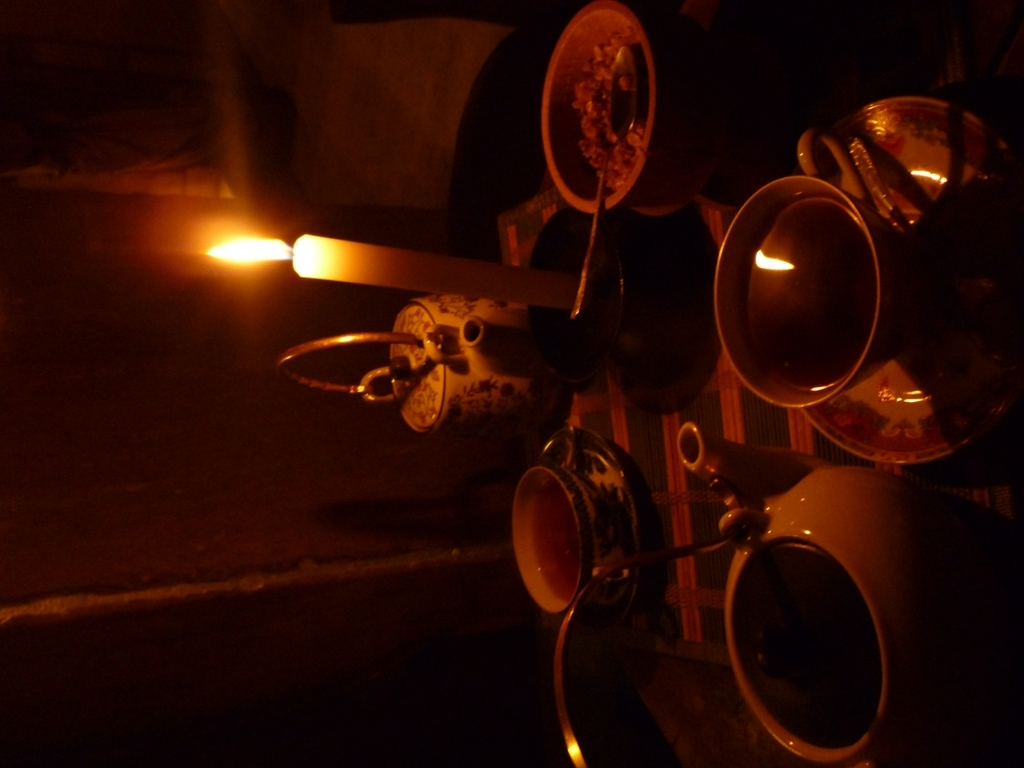Can you describe the atmosphere or mood that the image is trying to convey? The image exudes a warm and intimate ambiance, likely captured during a serene moment. The soft glow of the candle suggests a calm and possibly romantic setting, where individuals might be enjoying a quiet evening together. The use of shadows and the warm light convey intimacy and coziness, inviting the viewer to imagine sitting at the table, sharing in the moment of tranquility. 